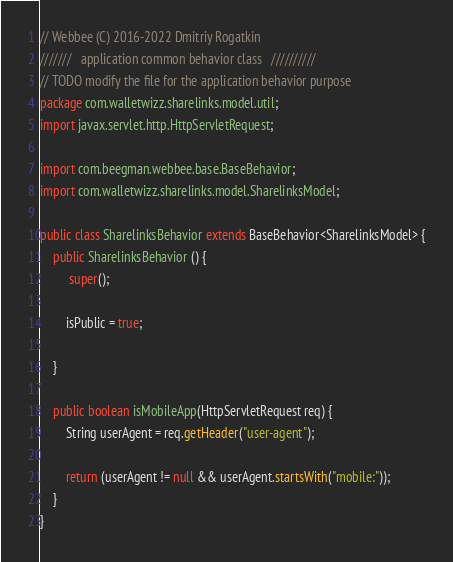<code> <loc_0><loc_0><loc_500><loc_500><_Java_>// Webbee (C) 2016-2022 Dmitriy Rogatkin
///////   application common behavior class   //////////
// TODO modify the file for the application behavior purpose
package com.walletwizz.sharelinks.model.util;
import javax.servlet.http.HttpServletRequest;

import com.beegman.webbee.base.BaseBehavior;
import com.walletwizz.sharelinks.model.SharelinksModel;

public class SharelinksBehavior extends BaseBehavior<SharelinksModel> {
    public SharelinksBehavior () {
         super();
               
        isPublic = true;

    }
    
    public boolean isMobileApp(HttpServletRequest req) {
		String userAgent = req.getHeader("user-agent");

		return (userAgent != null && userAgent.startsWith("mobile:"));
	}
}
</code> 